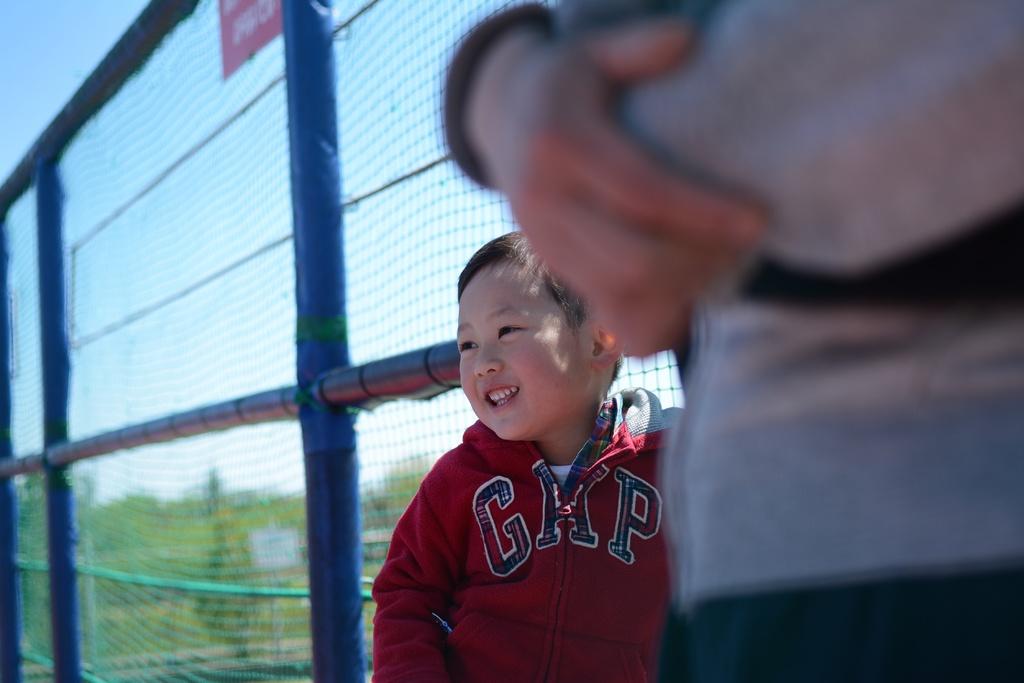What's on the boy's hoodie?
Ensure brevity in your answer.  Gap. 